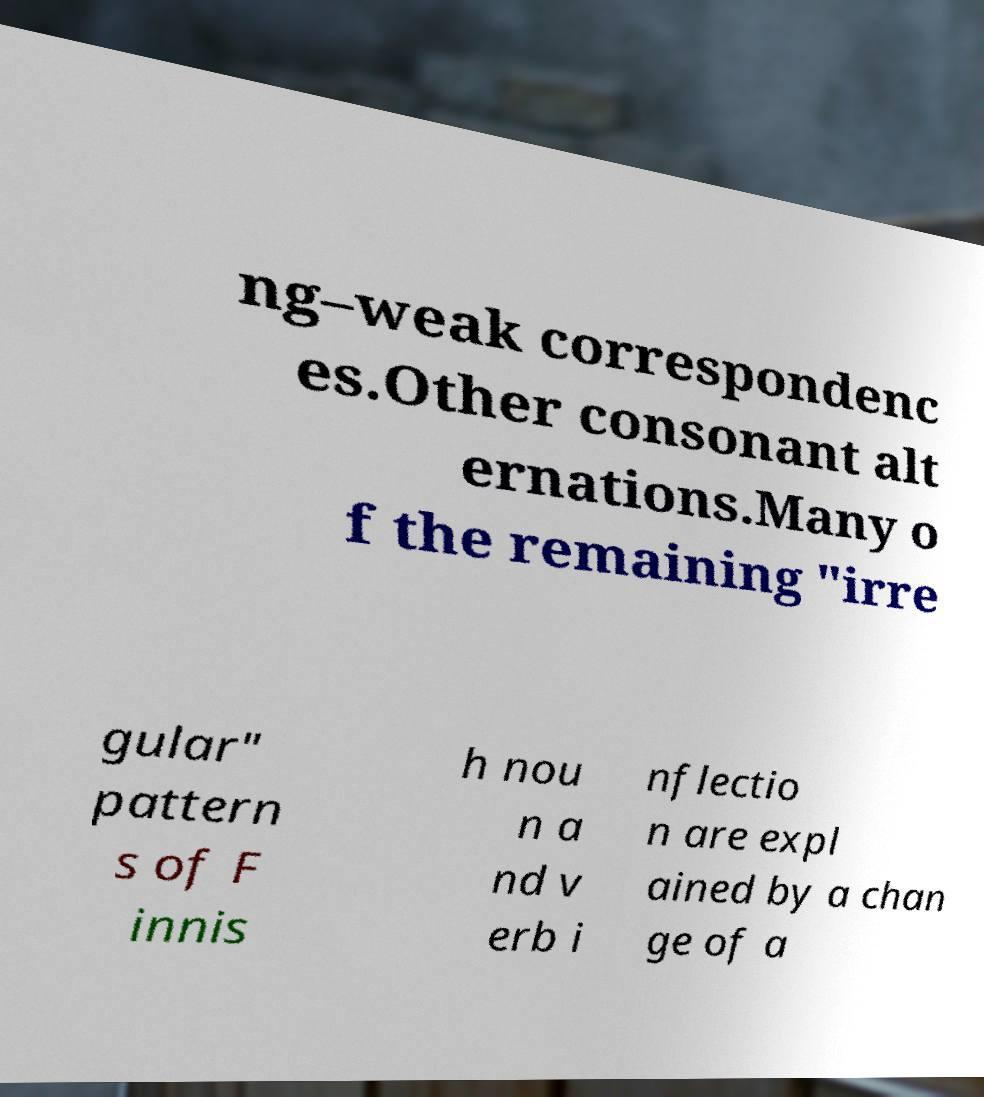Can you accurately transcribe the text from the provided image for me? ng–weak correspondenc es.Other consonant alt ernations.Many o f the remaining "irre gular" pattern s of F innis h nou n a nd v erb i nflectio n are expl ained by a chan ge of a 